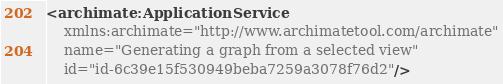Convert code to text. <code><loc_0><loc_0><loc_500><loc_500><_XML_><archimate:ApplicationService
    xmlns:archimate="http://www.archimatetool.com/archimate"
    name="Generating a graph from a selected view"
    id="id-6c39e15f530949beba7259a3078f76d2"/>
</code> 